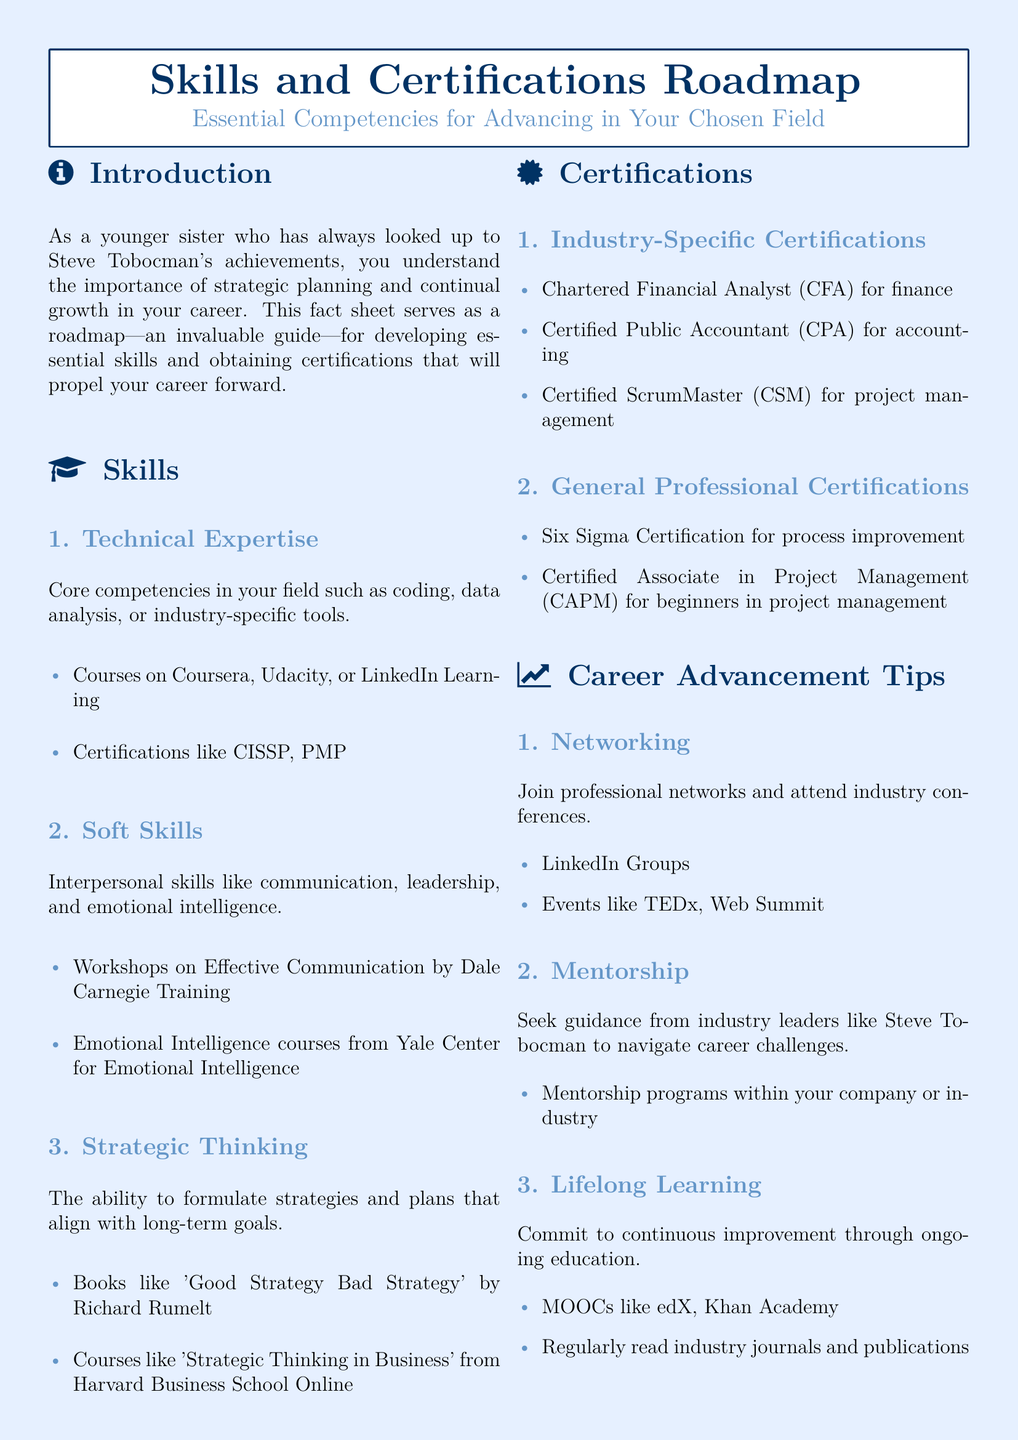What are the core competencies in your field? The document lists technical expertise, soft skills, and strategic thinking as core competencies.
Answer: Technical expertise, soft skills, strategic thinking What is a certification for project management? The document identifies Certified ScrumMaster (CSM) as a certification in project management.
Answer: Certified ScrumMaster (CSM) Which organization offers courses on emotional intelligence? Courses on emotional intelligence from Yale Center for Emotional Intelligence are mentioned in the document.
Answer: Yale Center for Emotional Intelligence What is one tip for career advancement? The document suggests lifelong learning as one of the tips for career advancement.
Answer: Lifelong learning How many types of certifications are listed? The document categorizes certifications into industry-specific and general professional, counting as two types.
Answer: 2 What book is suggested for strategic thinking? 'Good Strategy Bad Strategy' by Richard Rumelt is the book recommended for strategic thinking.
Answer: Good Strategy Bad Strategy What is a resource for technical skills development? The document recommends platforms like Coursera, Udacity, or LinkedIn Learning for technical skills development.
Answer: Coursera, Udacity, LinkedIn Learning Name one networking event mentioned. The document refers to events like TEDx or Web Summit for networking opportunities.
Answer: TEDx Which certification is for beginners in project management? The document mentions Certified Associate in Project Management (CAPM) as a certification for beginners in project management.
Answer: Certified Associate in Project Management (CAPM) 